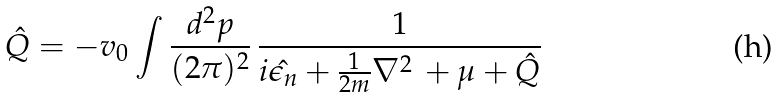<formula> <loc_0><loc_0><loc_500><loc_500>\hat { Q } = - { v _ { 0 } } \int \frac { { d ^ { 2 } } p } { ( 2 \pi ) ^ { 2 } } \, \frac { 1 } { i \hat { \epsilon _ { n } } + \frac { 1 } { 2 m } { \nabla ^ { 2 } } \, + \mu + \hat { Q } }</formula> 